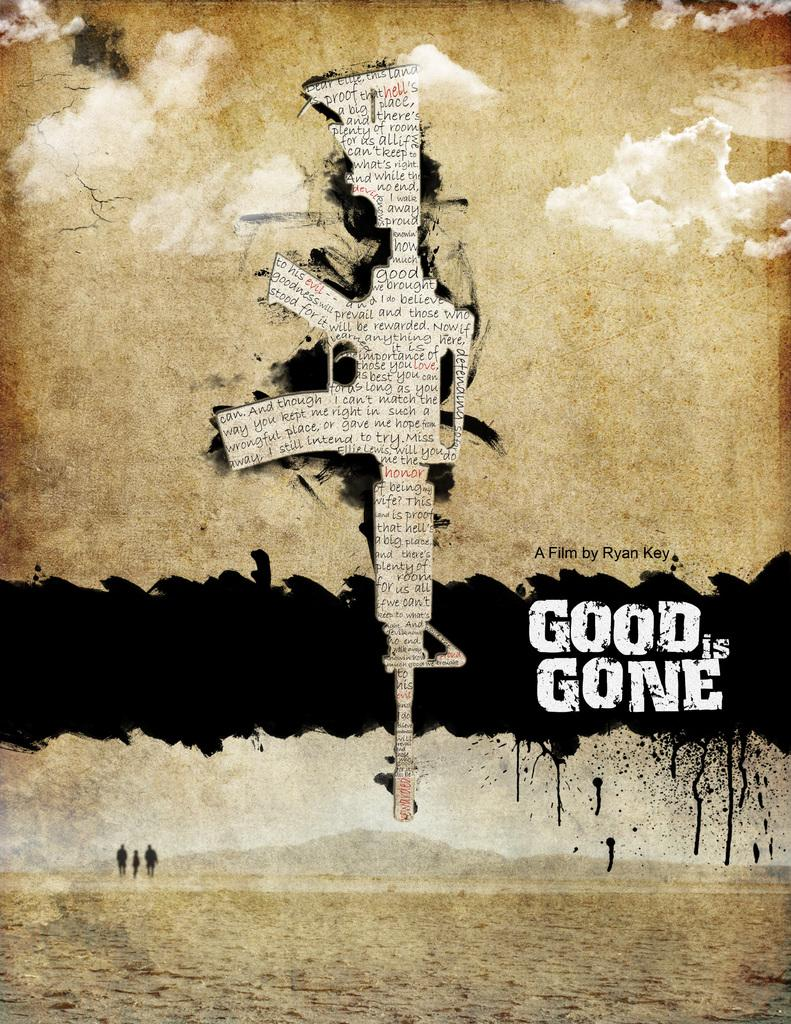Provide a one-sentence caption for the provided image. A movie poster for Good is Gone features a rifle made of newsprint with the muzzle facing the ground. 